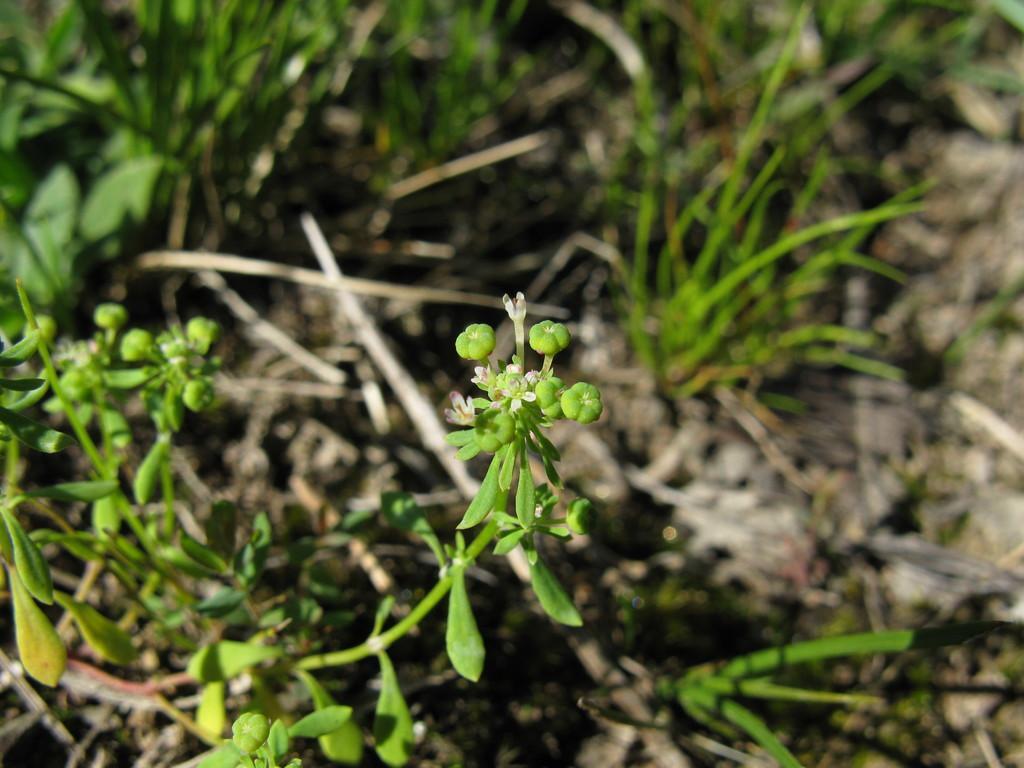Describe this image in one or two sentences. Here we can see planets and this is grass. 